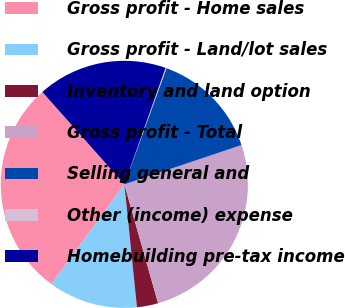Convert chart to OTSL. <chart><loc_0><loc_0><loc_500><loc_500><pie_chart><fcel>Gross profit - Home sales<fcel>Gross profit - Land/lot sales<fcel>Inventory and land option<fcel>Gross profit - Total<fcel>Selling general and<fcel>Other (income) expense<fcel>Homebuilding pre-tax income<nl><fcel>28.4%<fcel>11.67%<fcel>2.78%<fcel>25.75%<fcel>14.31%<fcel>0.13%<fcel>16.96%<nl></chart> 